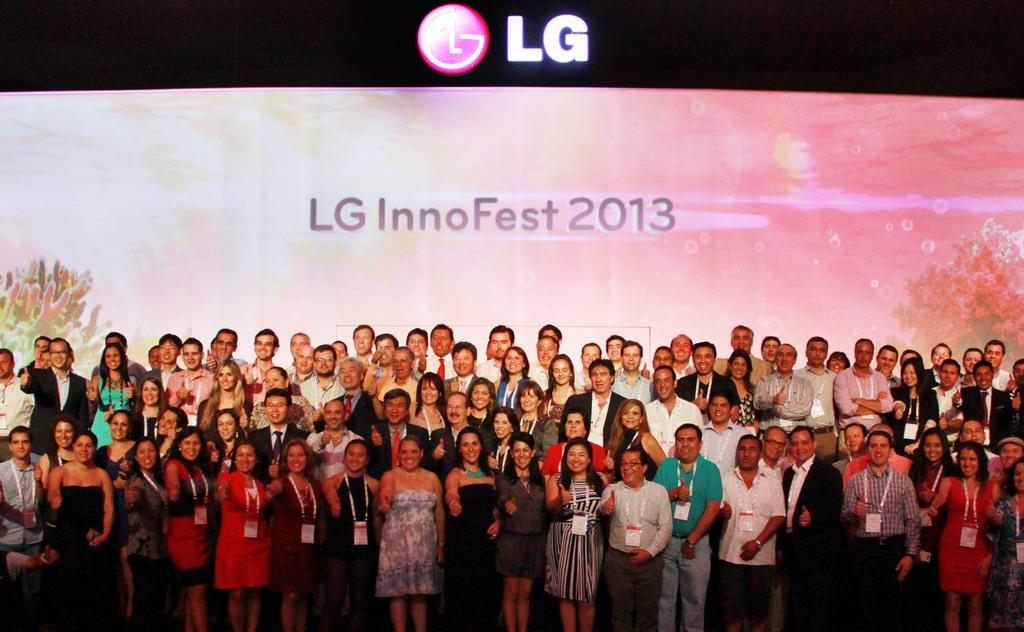Could you give a brief overview of what you see in this image? In this image at the bottom we can see people are standing and in the background we can see the screen. 